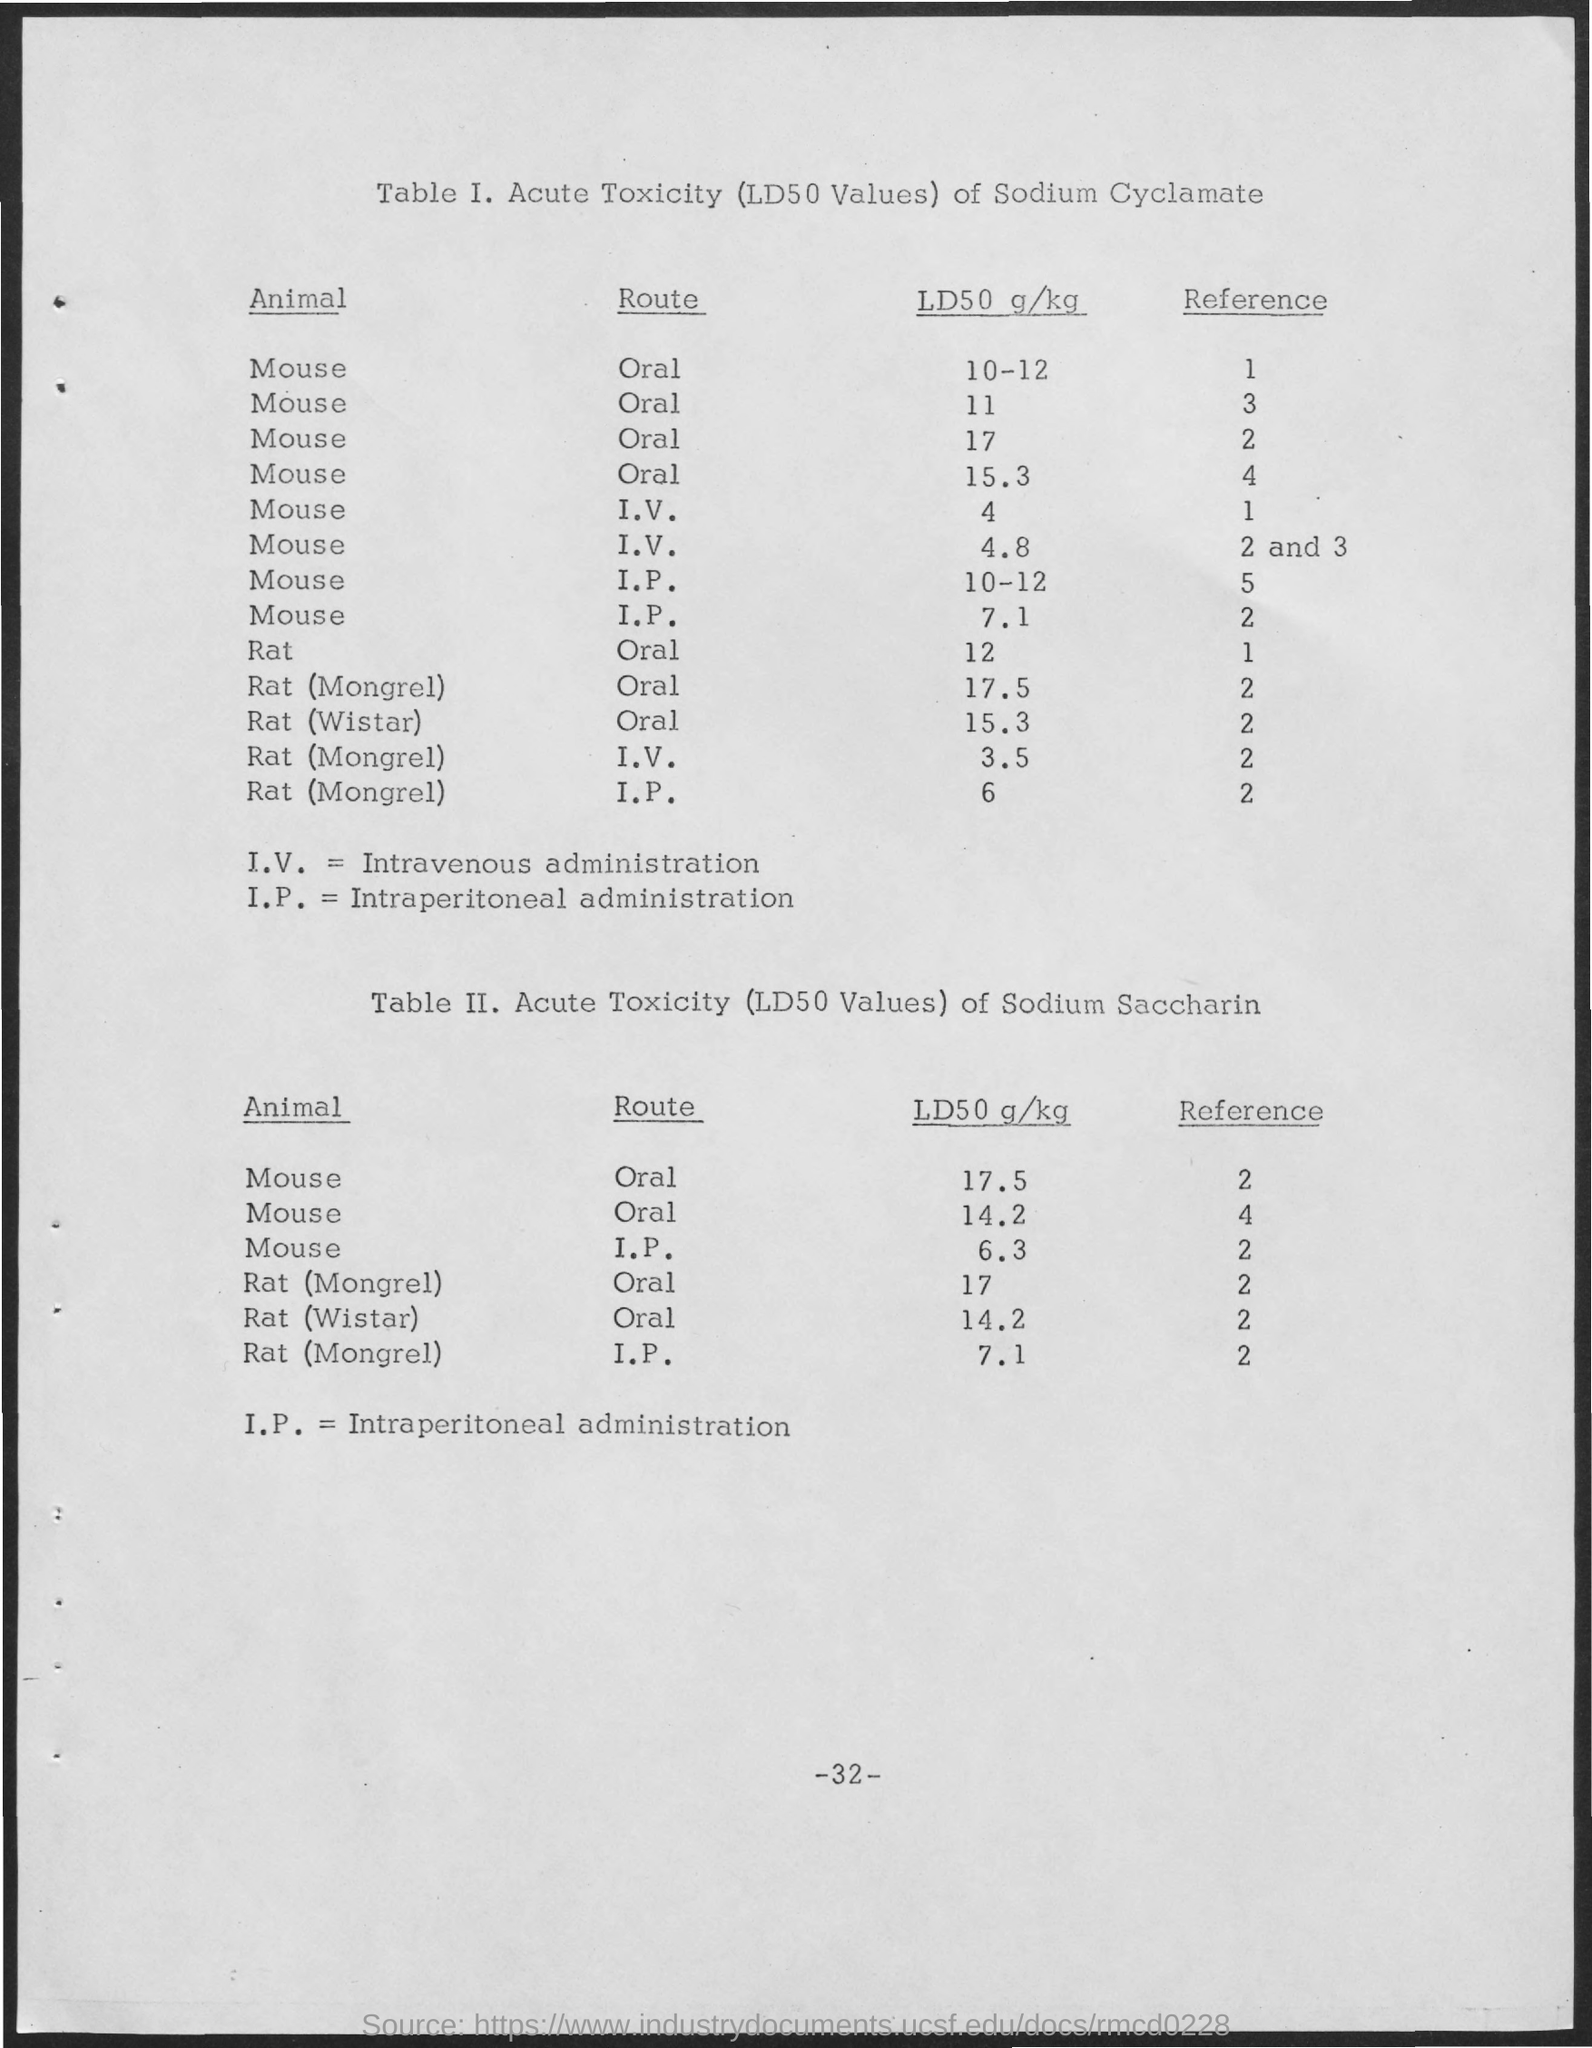Outline some significant characteristics in this image. Intraperitoneal administration is the process of delivering a substance directly into the peritoneal cavity, which is a thin-walled sac that contains the stomach, small intestine, and other abdominal organs. Intravenous administration, commonly referred to as I.V, is a method of delivering medication or fluids directly into a vein using a needle or catheter. 